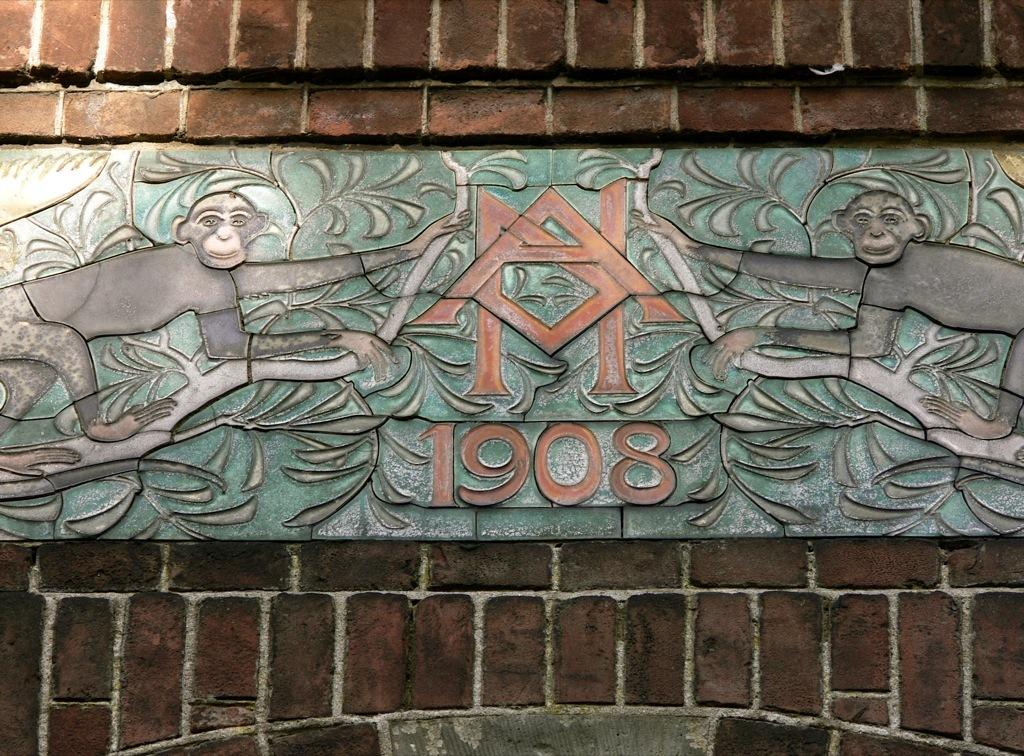What can be seen on the wall in the image? There is a carving on the wall in the image. What else is visible in the background of the image? There is a wall visible in the background of the image. What type of zinc activity is taking place in the image? There is no zinc activity present in the image. How many cents are visible in the image? There are no cents visible in the image. 